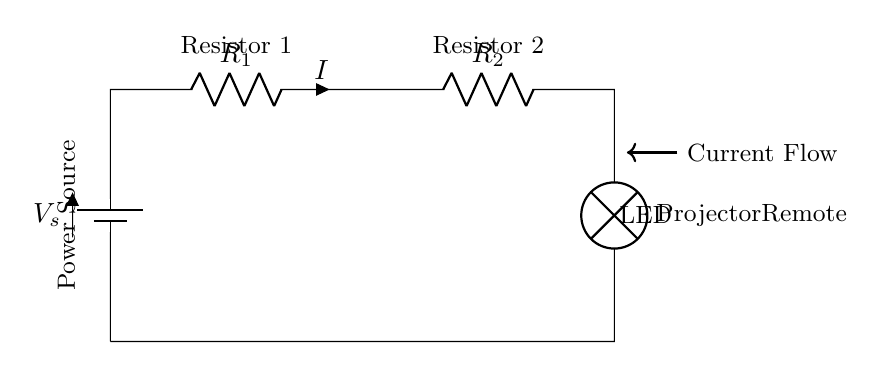What is the power source of this circuit? The power source is a battery, indicated in the diagram. It supplies the voltage needed for the circuit to operate.
Answer: battery How many resistors are present in the circuit? There are two resistors, labeled as R1 and R2 in the circuit diagram. They are connected in series before the projector.
Answer: 2 What is the function of the lamp in this circuit? The lamp provides visual feedback that the remote control is powered on. In this case, it is represented as the projector’s remote.
Answer: visual feedback What does the arrow indicate in the circuit diagram? The arrow represents the direction of current flow through the circuit. It shows where the current is moving from the power source through the resistors and to the projector's remote.
Answer: current flow If R1 has a higher resistance than R2, how does it affect the current passing through the circuit? In a series circuit, the total current is the same through all components. If R1 has a higher resistance, it limits the total current that can flow through R2 and the projector's remote, resulting in a lower total current in the circuit.
Answer: lower current What happens to the brightness of the lamp if one resistor is removed from the circuit? Removing a resistor from a series circuit decreases the total resistance, which increases the current and can make the lamp brighter, as more current flows through it.
Answer: increases brightness What is the relationship between the resistors in this series circuit? The total resistance in a series circuit is the sum of all individual resistances. Therefore, R1 and R2 add together to form the total resistance that affects the current flow.
Answer: additive 